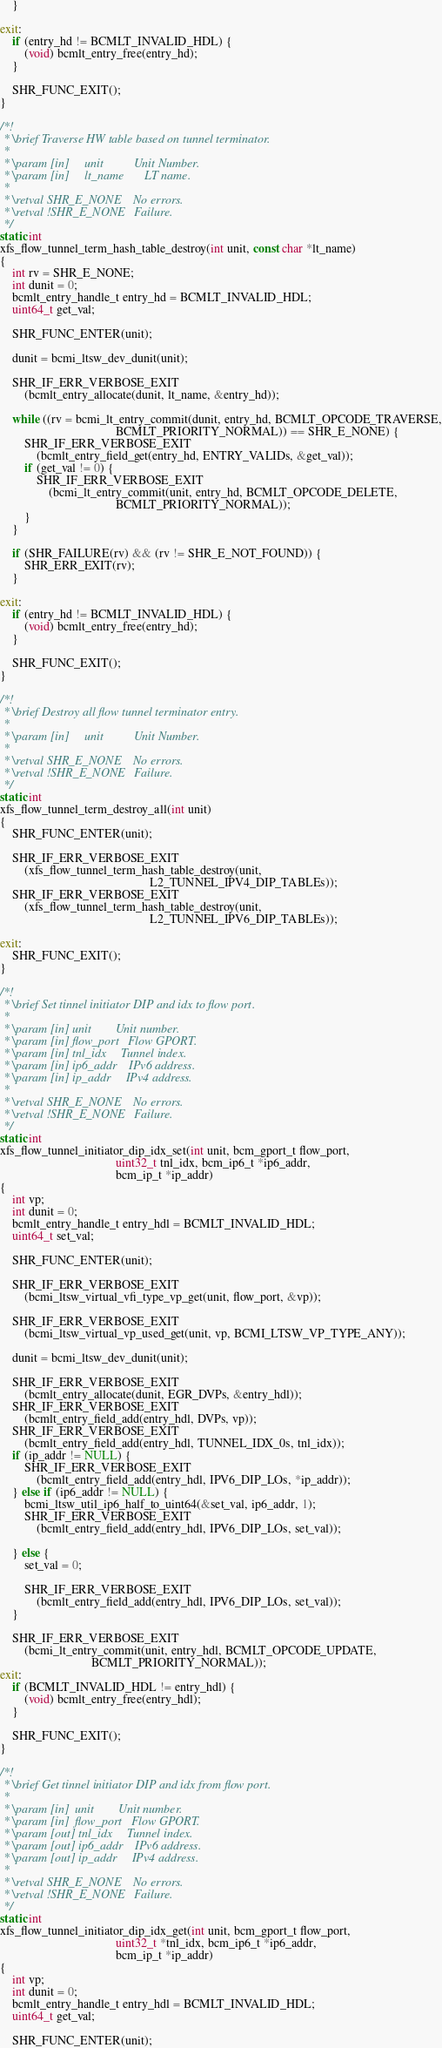Convert code to text. <code><loc_0><loc_0><loc_500><loc_500><_C_>    }

exit:
    if (entry_hd != BCMLT_INVALID_HDL) {
        (void) bcmlt_entry_free(entry_hd);
    }

    SHR_FUNC_EXIT();
}

/*!
 * \brief Traverse HW table based on tunnel terminator.
 *
 * \param [in]     unit          Unit Number.
 * \param [in]     lt_name       LT name.
 *
 * \retval SHR_E_NONE    No errors.
 * \retval !SHR_E_NONE   Failure.
 */
static int
xfs_flow_tunnel_term_hash_table_destroy(int unit, const char *lt_name)
{
    int rv = SHR_E_NONE;
    int dunit = 0;
    bcmlt_entry_handle_t entry_hd = BCMLT_INVALID_HDL;
    uint64_t get_val;

    SHR_FUNC_ENTER(unit);

    dunit = bcmi_ltsw_dev_dunit(unit);

    SHR_IF_ERR_VERBOSE_EXIT
        (bcmlt_entry_allocate(dunit, lt_name, &entry_hd));

    while ((rv = bcmi_lt_entry_commit(dunit, entry_hd, BCMLT_OPCODE_TRAVERSE,
                                      BCMLT_PRIORITY_NORMAL)) == SHR_E_NONE) {
        SHR_IF_ERR_VERBOSE_EXIT
            (bcmlt_entry_field_get(entry_hd, ENTRY_VALIDs, &get_val));
        if (get_val != 0) {
            SHR_IF_ERR_VERBOSE_EXIT
                (bcmi_lt_entry_commit(unit, entry_hd, BCMLT_OPCODE_DELETE,
                                      BCMLT_PRIORITY_NORMAL));
        }
    }

    if (SHR_FAILURE(rv) && (rv != SHR_E_NOT_FOUND)) {
        SHR_ERR_EXIT(rv);
    }

exit:
    if (entry_hd != BCMLT_INVALID_HDL) {
        (void) bcmlt_entry_free(entry_hd);
    }

    SHR_FUNC_EXIT();
}

/*!
 * \brief Destroy all flow tunnel terminator entry.
 *
 * \param [in]     unit          Unit Number.
 *
 * \retval SHR_E_NONE    No errors.
 * \retval !SHR_E_NONE   Failure.
 */
static int
xfs_flow_tunnel_term_destroy_all(int unit)
{
    SHR_FUNC_ENTER(unit);

    SHR_IF_ERR_VERBOSE_EXIT
        (xfs_flow_tunnel_term_hash_table_destroy(unit,
                                                 L2_TUNNEL_IPV4_DIP_TABLEs));
    SHR_IF_ERR_VERBOSE_EXIT
        (xfs_flow_tunnel_term_hash_table_destroy(unit,
                                                 L2_TUNNEL_IPV6_DIP_TABLEs));

exit:
    SHR_FUNC_EXIT();
}

/*!
 * \brief Set tinnel initiator DIP and idx to flow port.
 *
 * \param [in] unit        Unit number.
 * \param [in] flow_port   Flow GPORT.
 * \param [in] tnl_idx     Tunnel index.
 * \param [in] ip6_addr    IPv6 address.
 * \param [in] ip_addr     IPv4 address.
 *
 * \retval SHR_E_NONE    No errors.
 * \retval !SHR_E_NONE   Failure.
 */
static int
xfs_flow_tunnel_initiator_dip_idx_set(int unit, bcm_gport_t flow_port,
                                      uint32_t tnl_idx, bcm_ip6_t *ip6_addr,
                                      bcm_ip_t *ip_addr)
{
    int vp;
    int dunit = 0;
    bcmlt_entry_handle_t entry_hdl = BCMLT_INVALID_HDL;
    uint64_t set_val;

    SHR_FUNC_ENTER(unit);

    SHR_IF_ERR_VERBOSE_EXIT
        (bcmi_ltsw_virtual_vfi_type_vp_get(unit, flow_port, &vp));

    SHR_IF_ERR_VERBOSE_EXIT
        (bcmi_ltsw_virtual_vp_used_get(unit, vp, BCMI_LTSW_VP_TYPE_ANY));

    dunit = bcmi_ltsw_dev_dunit(unit);

    SHR_IF_ERR_VERBOSE_EXIT
        (bcmlt_entry_allocate(dunit, EGR_DVPs, &entry_hdl));
    SHR_IF_ERR_VERBOSE_EXIT
        (bcmlt_entry_field_add(entry_hdl, DVPs, vp));
    SHR_IF_ERR_VERBOSE_EXIT
        (bcmlt_entry_field_add(entry_hdl, TUNNEL_IDX_0s, tnl_idx));
    if (ip_addr != NULL) {
        SHR_IF_ERR_VERBOSE_EXIT
            (bcmlt_entry_field_add(entry_hdl, IPV6_DIP_LOs, *ip_addr));
    } else if (ip6_addr != NULL) {
        bcmi_ltsw_util_ip6_half_to_uint64(&set_val, ip6_addr, 1);
        SHR_IF_ERR_VERBOSE_EXIT
            (bcmlt_entry_field_add(entry_hdl, IPV6_DIP_LOs, set_val));

    } else {
        set_val = 0;

        SHR_IF_ERR_VERBOSE_EXIT
            (bcmlt_entry_field_add(entry_hdl, IPV6_DIP_LOs, set_val));
    }

    SHR_IF_ERR_VERBOSE_EXIT
        (bcmi_lt_entry_commit(unit, entry_hdl, BCMLT_OPCODE_UPDATE,
                              BCMLT_PRIORITY_NORMAL));
exit:
    if (BCMLT_INVALID_HDL != entry_hdl) {
        (void) bcmlt_entry_free(entry_hdl);
    }

    SHR_FUNC_EXIT();
}

/*!
 * \brief Get tinnel initiator DIP and idx from flow port.
 *
 * \param [in]  unit        Unit number.
 * \param [in]  flow_port   Flow GPORT.
 * \param [out] tnl_idx     Tunnel index.
 * \param [out] ip6_addr    IPv6 address.
 * \param [out] ip_addr     IPv4 address.
 *
 * \retval SHR_E_NONE    No errors.
 * \retval !SHR_E_NONE   Failure.
 */
static int
xfs_flow_tunnel_initiator_dip_idx_get(int unit, bcm_gport_t flow_port,
                                      uint32_t *tnl_idx, bcm_ip6_t *ip6_addr,
                                      bcm_ip_t *ip_addr)
{
    int vp;
    int dunit = 0;
    bcmlt_entry_handle_t entry_hdl = BCMLT_INVALID_HDL;
    uint64_t get_val;

    SHR_FUNC_ENTER(unit);
</code> 